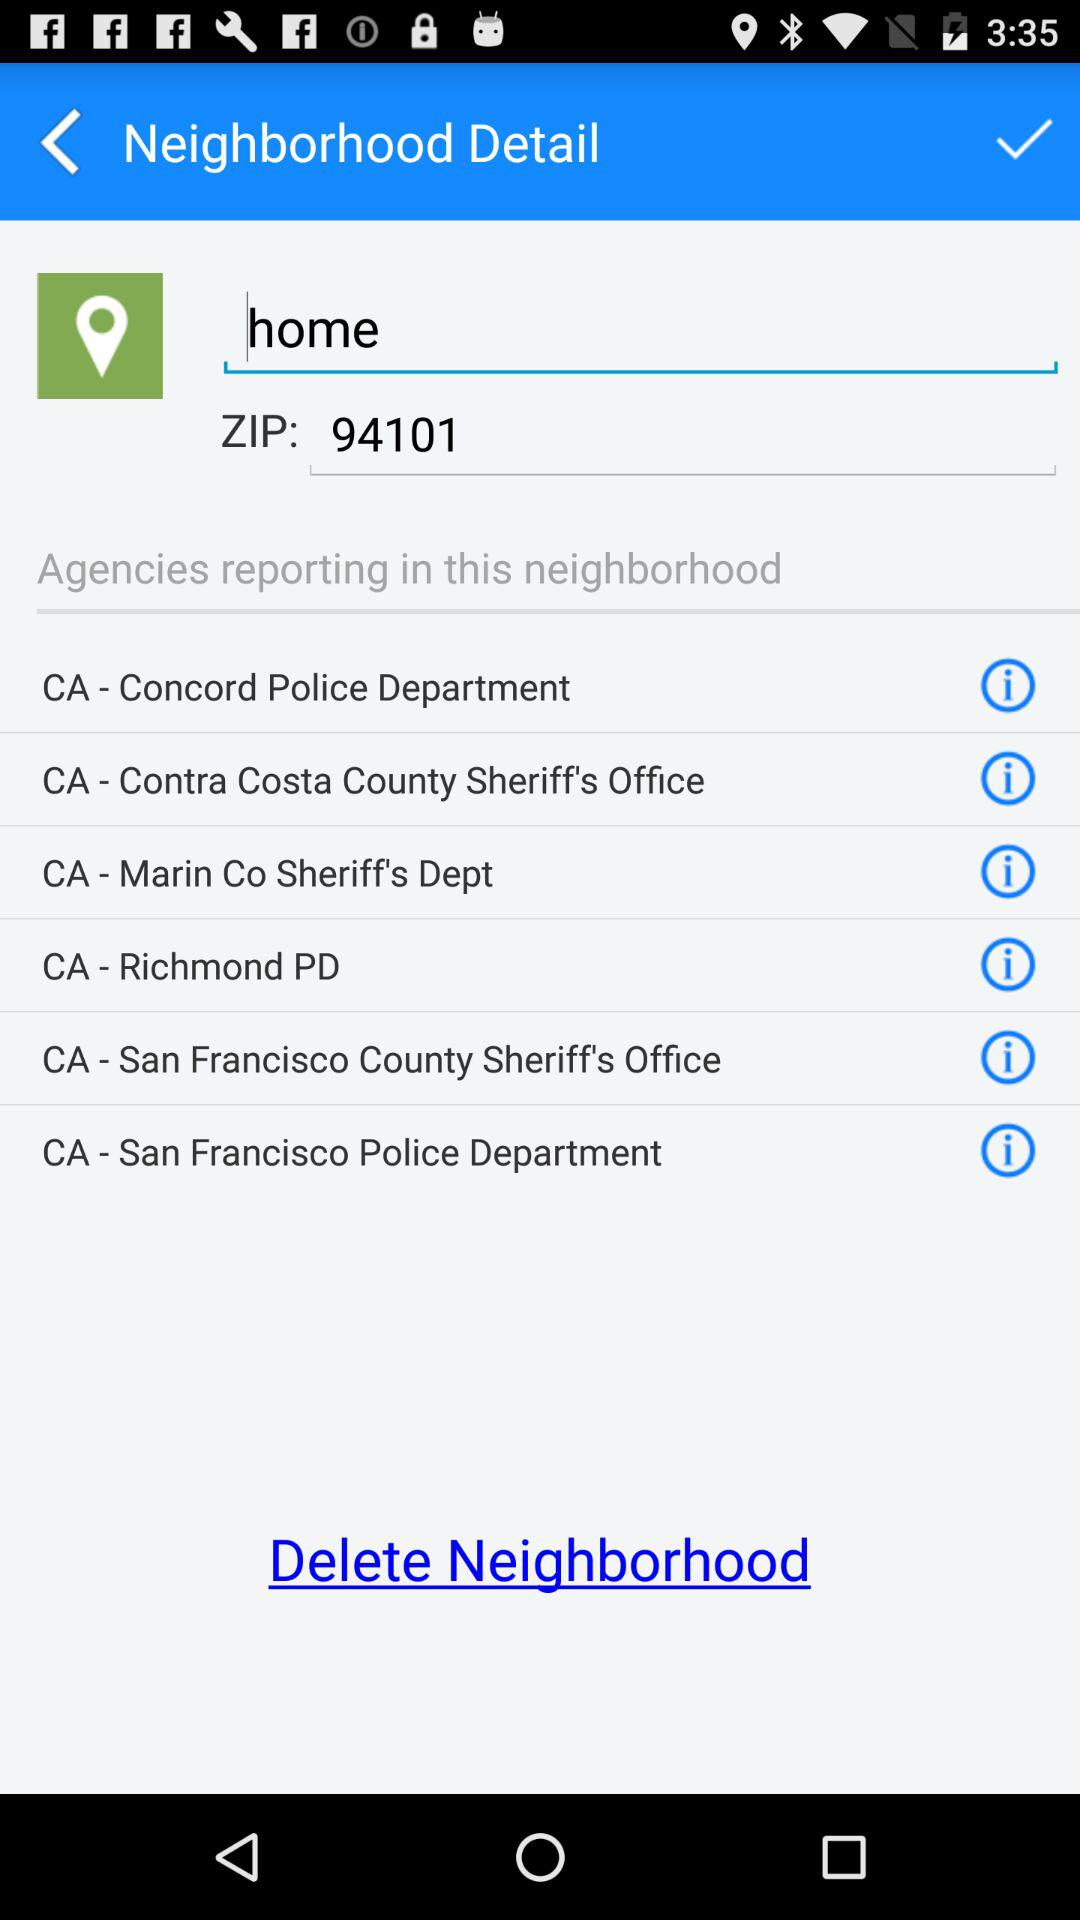What is the term entered in the search box? The term entered in the search box is "home". 